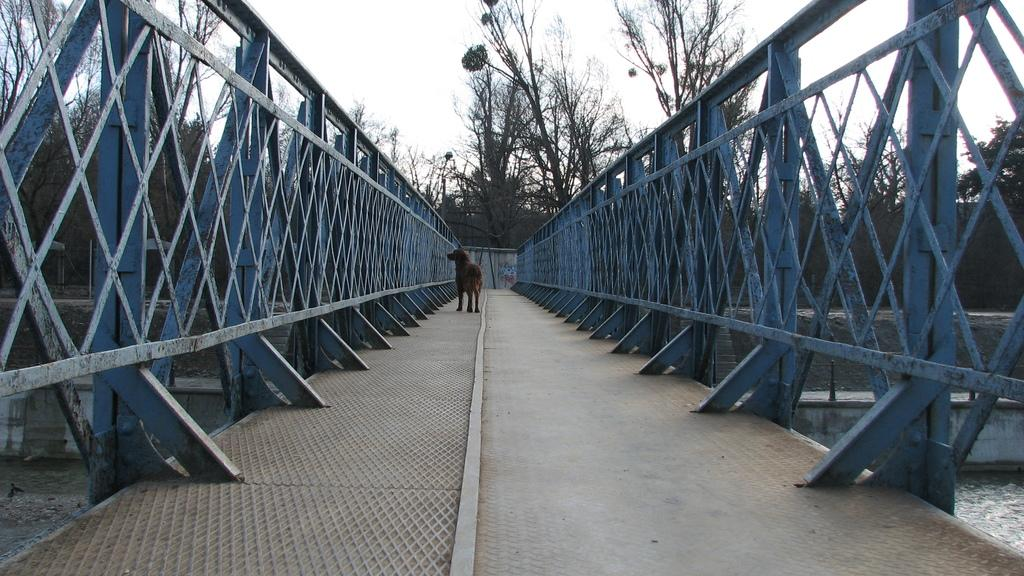What animal is present in the image? There is a dog in the image. Where is the dog located? The dog is standing on a bridge. What feature does the bridge have? The bridge has fences on both sides. What can be seen below the bridge? There is water visible at the bottom of the image. What type of vegetation is visible in the background? There are trees in the background of the image. What is visible at the top of the image? The sky is visible at the top of the image. What type of hall can be seen in the image? There is no hall present in the image; it features a dog standing on a bridge with a background of trees and sky. How does the dog say good-bye to the person in the image? The image does not depict any interaction between the dog and a person, nor does it show the dog saying good-bye. 